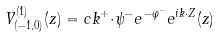Convert formula to latex. <formula><loc_0><loc_0><loc_500><loc_500>V ^ { ( 1 ) } _ { ( { - } 1 , 0 ) } ( z ) = c k ^ { + } { \cdot } \psi ^ { - } e ^ { - \varphi ^ { - } } e ^ { i k { \cdot } Z } ( z )</formula> 